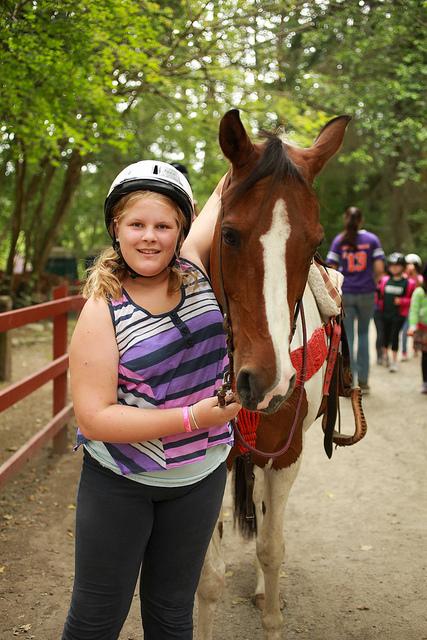Is the horse in a barn?
Give a very brief answer. No. What color is the girl's helmet?
Write a very short answer. White. What animal is in the scene?
Write a very short answer. Horse. 